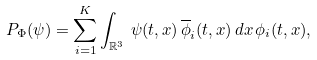Convert formula to latex. <formula><loc_0><loc_0><loc_500><loc_500>P _ { \Phi } ( \psi ) = \sum _ { i = 1 } ^ { K } \int _ { \mathbb { R } ^ { 3 } } \, \psi ( t , x ) \, \overline { \phi } _ { i } ( t , x ) \, d x \, \phi _ { i } ( t , x ) ,</formula> 